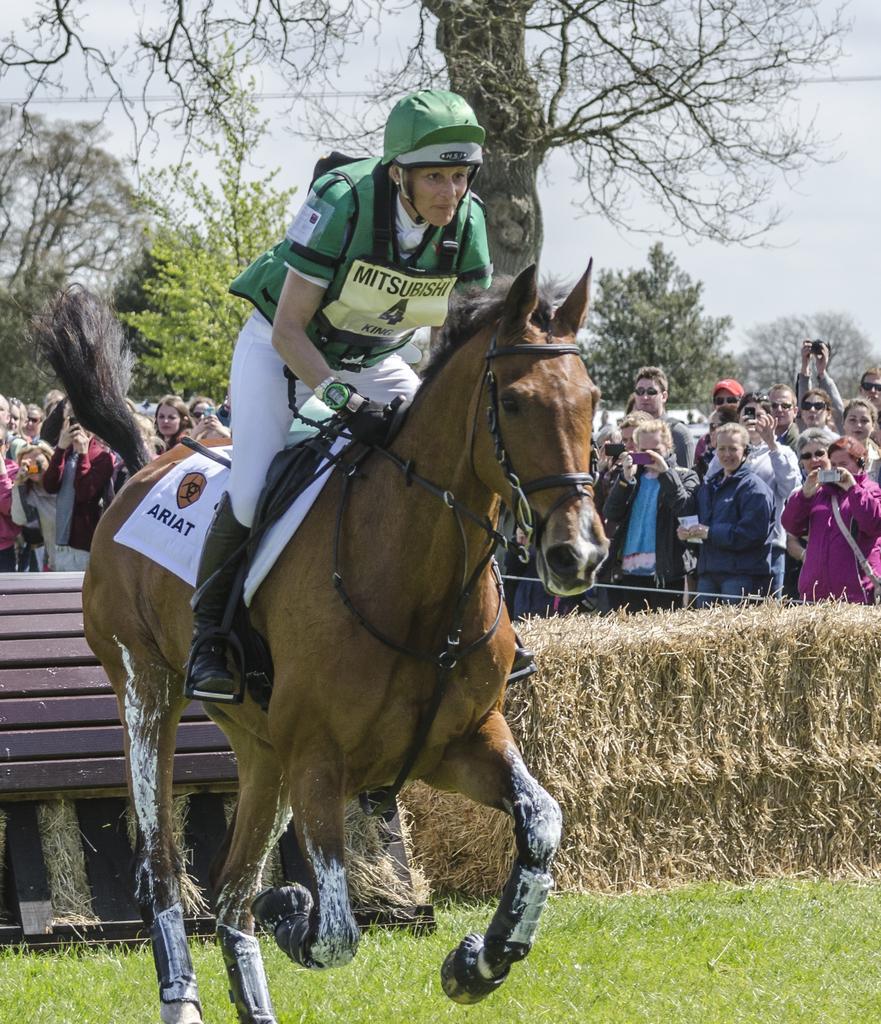Can you describe this image briefly? In this image there is the sky towards the top of the image, there are wires, there are trees, there are a group of persons standing, they are holding an object, there is grass towards the bottom of the image, there is a wooden object towards the left of the image, there is grass towards the right of the image, there is a horse running, there is a woman sitting on the horse, she is wearing a helmet. 